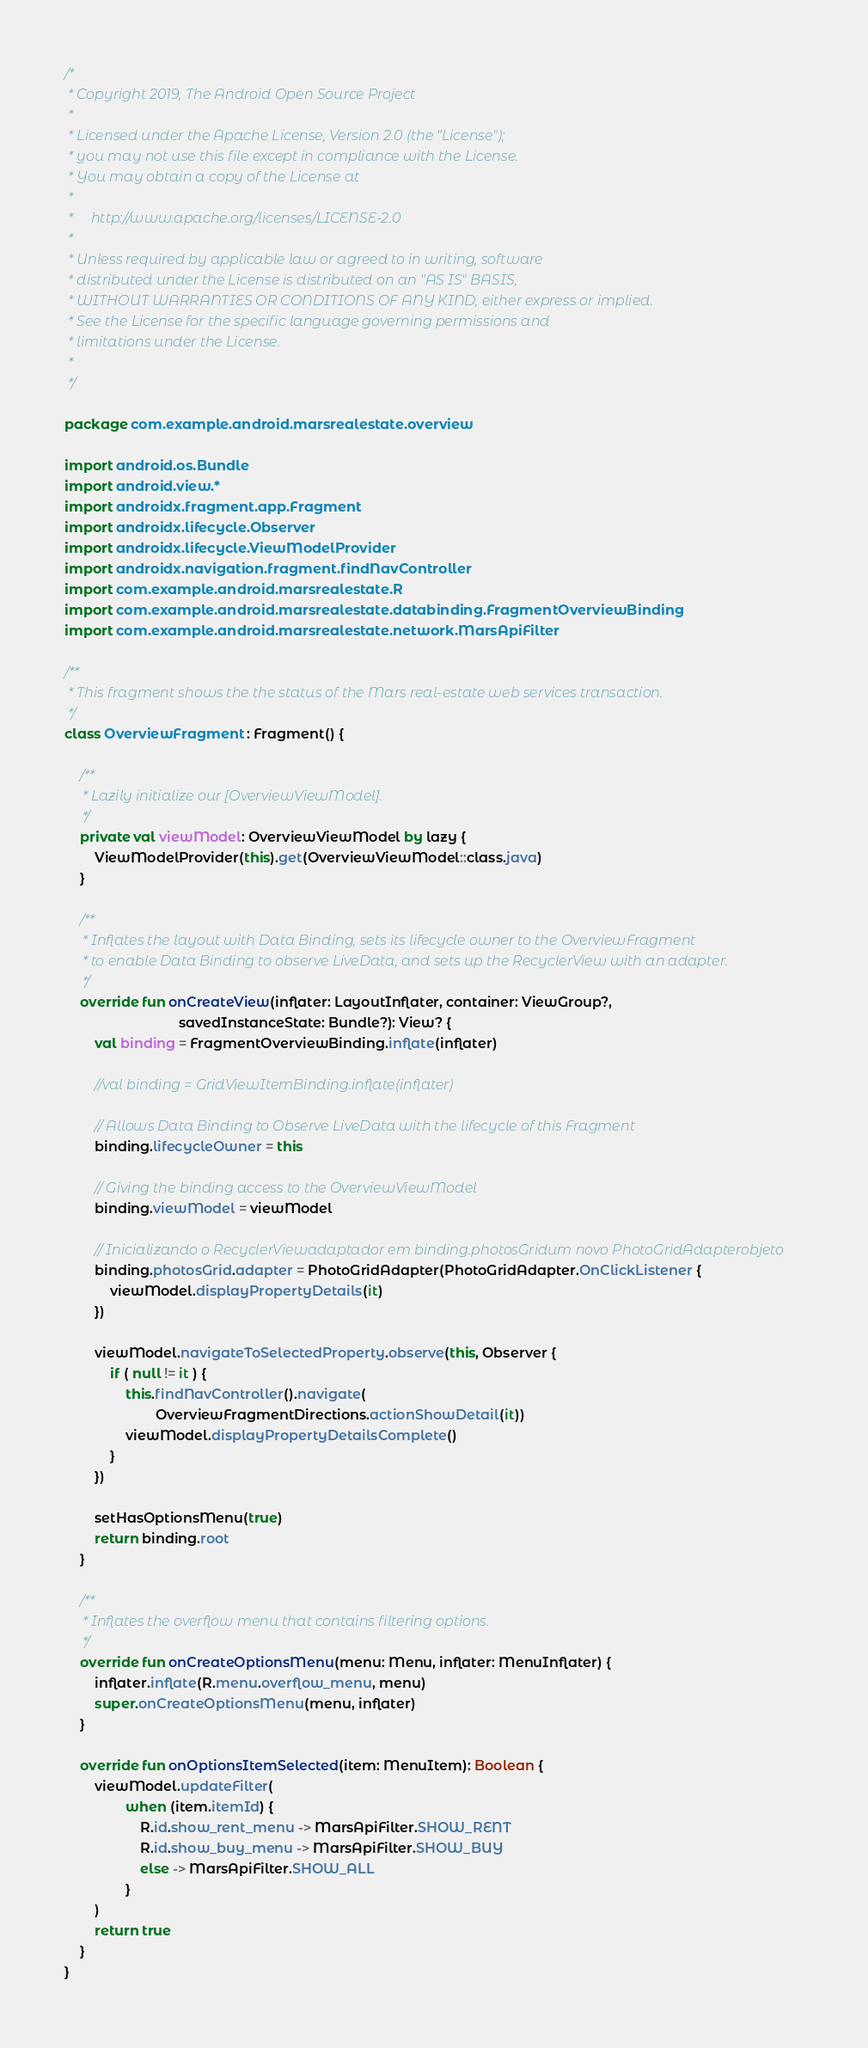<code> <loc_0><loc_0><loc_500><loc_500><_Kotlin_>/*
 * Copyright 2019, The Android Open Source Project
 *
 * Licensed under the Apache License, Version 2.0 (the "License");
 * you may not use this file except in compliance with the License.
 * You may obtain a copy of the License at
 *
 *     http://www.apache.org/licenses/LICENSE-2.0
 *
 * Unless required by applicable law or agreed to in writing, software
 * distributed under the License is distributed on an "AS IS" BASIS,
 * WITHOUT WARRANTIES OR CONDITIONS OF ANY KIND, either express or implied.
 * See the License for the specific language governing permissions and
 * limitations under the License.
 *
 */

package com.example.android.marsrealestate.overview

import android.os.Bundle
import android.view.*
import androidx.fragment.app.Fragment
import androidx.lifecycle.Observer
import androidx.lifecycle.ViewModelProvider
import androidx.navigation.fragment.findNavController
import com.example.android.marsrealestate.R
import com.example.android.marsrealestate.databinding.FragmentOverviewBinding
import com.example.android.marsrealestate.network.MarsApiFilter

/**
 * This fragment shows the the status of the Mars real-estate web services transaction.
 */
class OverviewFragment : Fragment() {

    /**
     * Lazily initialize our [OverviewViewModel].
     */
    private val viewModel: OverviewViewModel by lazy {
        ViewModelProvider(this).get(OverviewViewModel::class.java)
    }

    /**
     * Inflates the layout with Data Binding, sets its lifecycle owner to the OverviewFragment
     * to enable Data Binding to observe LiveData, and sets up the RecyclerView with an adapter.
     */
    override fun onCreateView(inflater: LayoutInflater, container: ViewGroup?,
                              savedInstanceState: Bundle?): View? {
        val binding = FragmentOverviewBinding.inflate(inflater)

        //val binding = GridViewItemBinding.inflate(inflater)

        // Allows Data Binding to Observe LiveData with the lifecycle of this Fragment
        binding.lifecycleOwner = this

        // Giving the binding access to the OverviewViewModel
        binding.viewModel = viewModel

        // Inicializando o RecyclerViewadaptador em binding.photosGridum novo PhotoGridAdapterobjeto
        binding.photosGrid.adapter = PhotoGridAdapter(PhotoGridAdapter.OnClickListener {
            viewModel.displayPropertyDetails(it)
        })

        viewModel.navigateToSelectedProperty.observe(this, Observer {
            if ( null != it ) {
                this.findNavController().navigate(
                        OverviewFragmentDirections.actionShowDetail(it))
                viewModel.displayPropertyDetailsComplete()
            }
        })

        setHasOptionsMenu(true)
        return binding.root
    }

    /**
     * Inflates the overflow menu that contains filtering options.
     */
    override fun onCreateOptionsMenu(menu: Menu, inflater: MenuInflater) {
        inflater.inflate(R.menu.overflow_menu, menu)
        super.onCreateOptionsMenu(menu, inflater)
    }

    override fun onOptionsItemSelected(item: MenuItem): Boolean {
        viewModel.updateFilter(
                when (item.itemId) {
                    R.id.show_rent_menu -> MarsApiFilter.SHOW_RENT
                    R.id.show_buy_menu -> MarsApiFilter.SHOW_BUY
                    else -> MarsApiFilter.SHOW_ALL
                }
        )
        return true
    }
}
</code> 